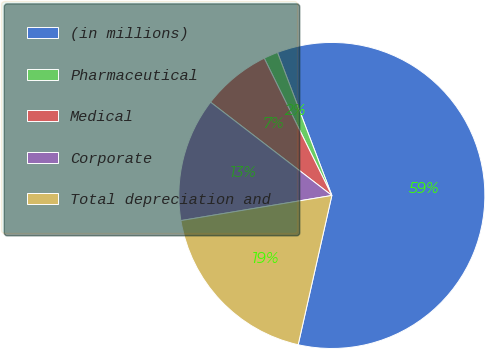Convert chart to OTSL. <chart><loc_0><loc_0><loc_500><loc_500><pie_chart><fcel>(in millions)<fcel>Pharmaceutical<fcel>Medical<fcel>Corporate<fcel>Total depreciation and<nl><fcel>59.31%<fcel>1.5%<fcel>7.28%<fcel>13.06%<fcel>18.84%<nl></chart> 